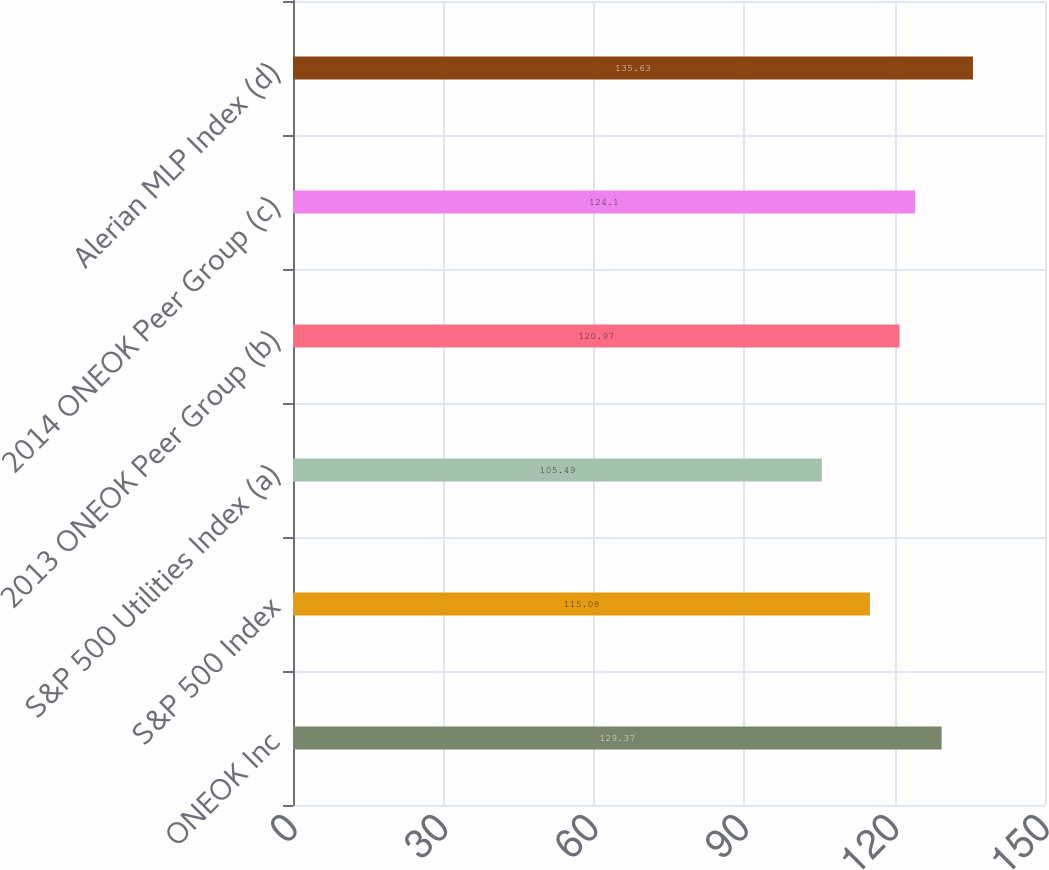<chart> <loc_0><loc_0><loc_500><loc_500><bar_chart><fcel>ONEOK Inc<fcel>S&P 500 Index<fcel>S&P 500 Utilities Index (a)<fcel>2013 ONEOK Peer Group (b)<fcel>2014 ONEOK Peer Group (c)<fcel>Alerian MLP Index (d)<nl><fcel>129.37<fcel>115.08<fcel>105.49<fcel>120.97<fcel>124.1<fcel>135.63<nl></chart> 